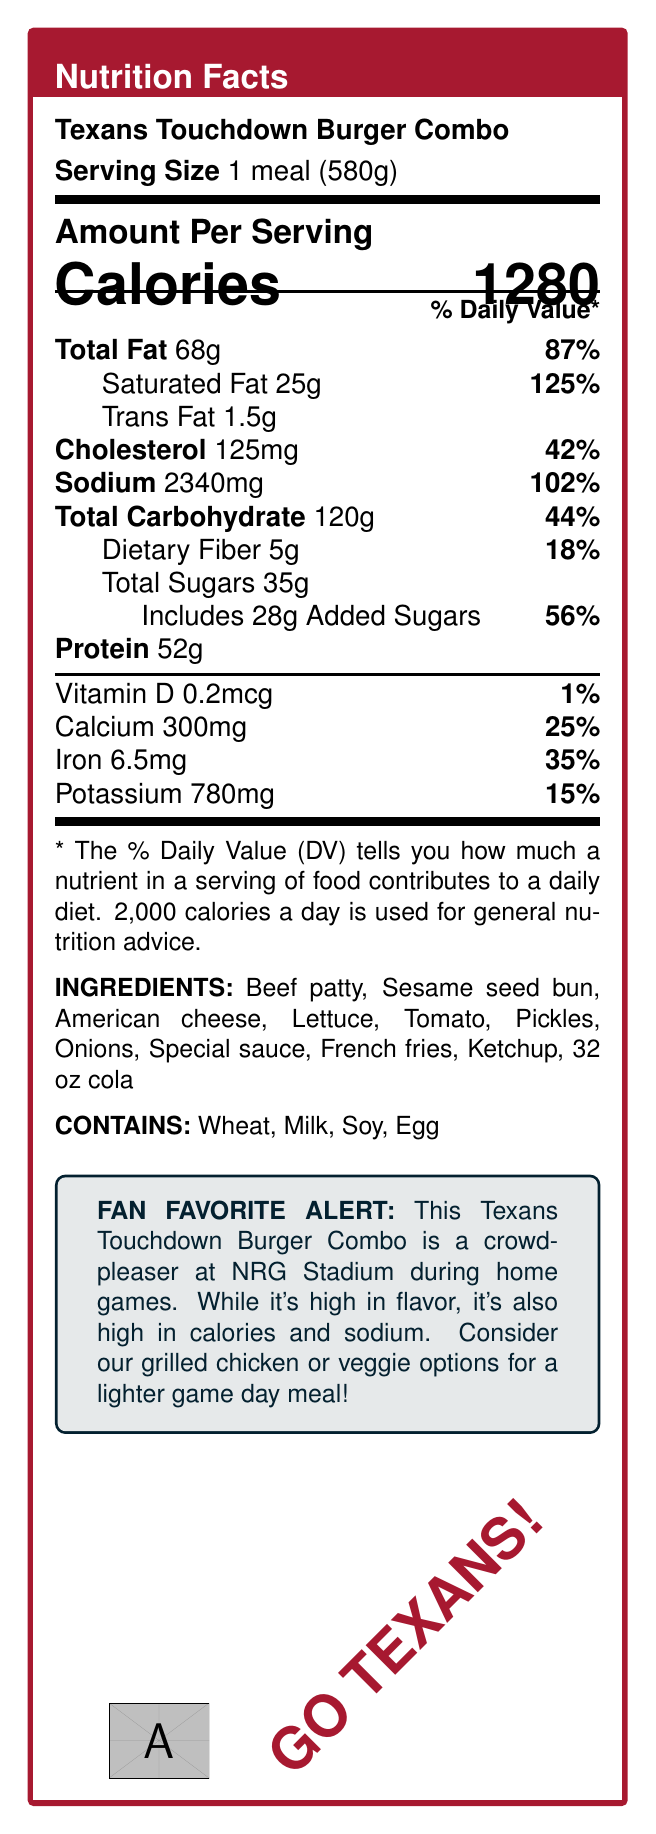what is the serving size for the Texans Touchdown Burger Combo? The document specifies the serving size as 1 meal weighing 580 grams.
Answer: 1 meal (580g) how many calories are in the Texans Touchdown Burger Combo? The document lists the calorie content as 1280 calories for one meal.
Answer: 1280 calories what is the percentage daily value of saturated fat in this meal? The document indicates that the saturated fat content is 25g, which is 125% of the daily value.
Answer: 125% which allergens are present in this meal? The document lists wheat, milk, soy, and egg as allergens contained in the meal.
Answer: Wheat, Milk, Soy, Egg how much protein does the Texans Touchdown Burger Combo have? The nutrition facts state that the meal contains 52 grams of protein.
Answer: 52g what is the total amount of carbohydrates in this meal? The document specifies that the total carbohydrate content is 120 grams.
Answer: 120g compare the percentage daily value of sodium to that of dietary fiber. The document reveals sodium has 102% of the daily value, while dietary fiber has 18%.
Answer: Sodium: 102%, Dietary Fiber: 18% what is the daily value percentage for calcium in this meal? The document states that the calcium content is 300mg, which is 25% of the daily value.
Answer: 25% choose the correct protein source in this meal:
A. Sesame seed bun
B. Tomato
C. Beef patty
D. Special sauce The document notes the protein source is primarily from the beef patty.
Answer: C. Beef patty identify the healthiest choice based on calorie content:
I. Texans Touchdown Burger Combo
II. Grilled chicken sandwich 
III. Veggie burger The document suggests that the grilled chicken sandwich is a lighter, healthier alternative.
Answer: II. Grilled chicken sandwich is the sodium content in the Texans Touchdown Burger Combo higher than the daily recommended intake? The document states a high sodium warning, indicating the meal contains more than the daily recommended sodium intake.
Answer: Yes summarize the main idea of the document. The document describes the nutritional values, potential allergens, and ingredients of the Texans Touchdown Burger Combo, emphasizing its popularity despite its high-calorie and high-sodium content, while recommending healthier options.
Answer: The document provides nutritional information for the Texans Touchdown Burger Combo, highlighting its high calorie, fat, and sodium content. It also includes ingredients, allergens, and healthier alternatives available at NRG Stadium concessions during Texans home games. what is the percentage daily value for added sugars? The document lists 28 grams of added sugars, which is 56% of the daily value.
Answer: 56% how much trans fat does the meal contain? The document indicates that there are 1.5 grams of trans fat in the meal.
Answer: 1.5g why might regular consumption of this meal affect athletic performance? The document includes a note explaining that the high calorie and fat content can impact athletic performance if consumed regularly.
Answer: High in calories and fat how many milligrams of potassium are in this meal? The document states that the meal contains 780 milligrams of potassium.
Answer: 780mg is the Texans Touchdown Burger Combo lactose-free? The meal contains milk, as stated in the allergens section.
Answer: No what is the popularity of the Texans Touchdown Burger Combo? The document mentions that the burger combo is a fan favorite during Texans home games.
Answer: Fan favorite during Texans home games how much vitamin D is in the meal? The document specifies that the vitamin D content is 0.2 micrograms.
Answer: 0.2mcg what is the source of calories from fat in this meal? The document mentions that 612 of the total 1280 calories come from fat.
Answer: 612 calories from fat can you list all the ingredients mentioned for the Texans Touchdown Burger Combo? The document provides a list of ingredients including all these items.
Answer: Beef patty, Sesame seed bun, American cheese, Lettuce, Tomato, Pickles, Onions, Special sauce, French fries, Ketchup, 32 oz cola does this document mention how often this meal should be consumed? The document does not provide explicit guidance on the frequency of consumption.
Answer: Not enough information 